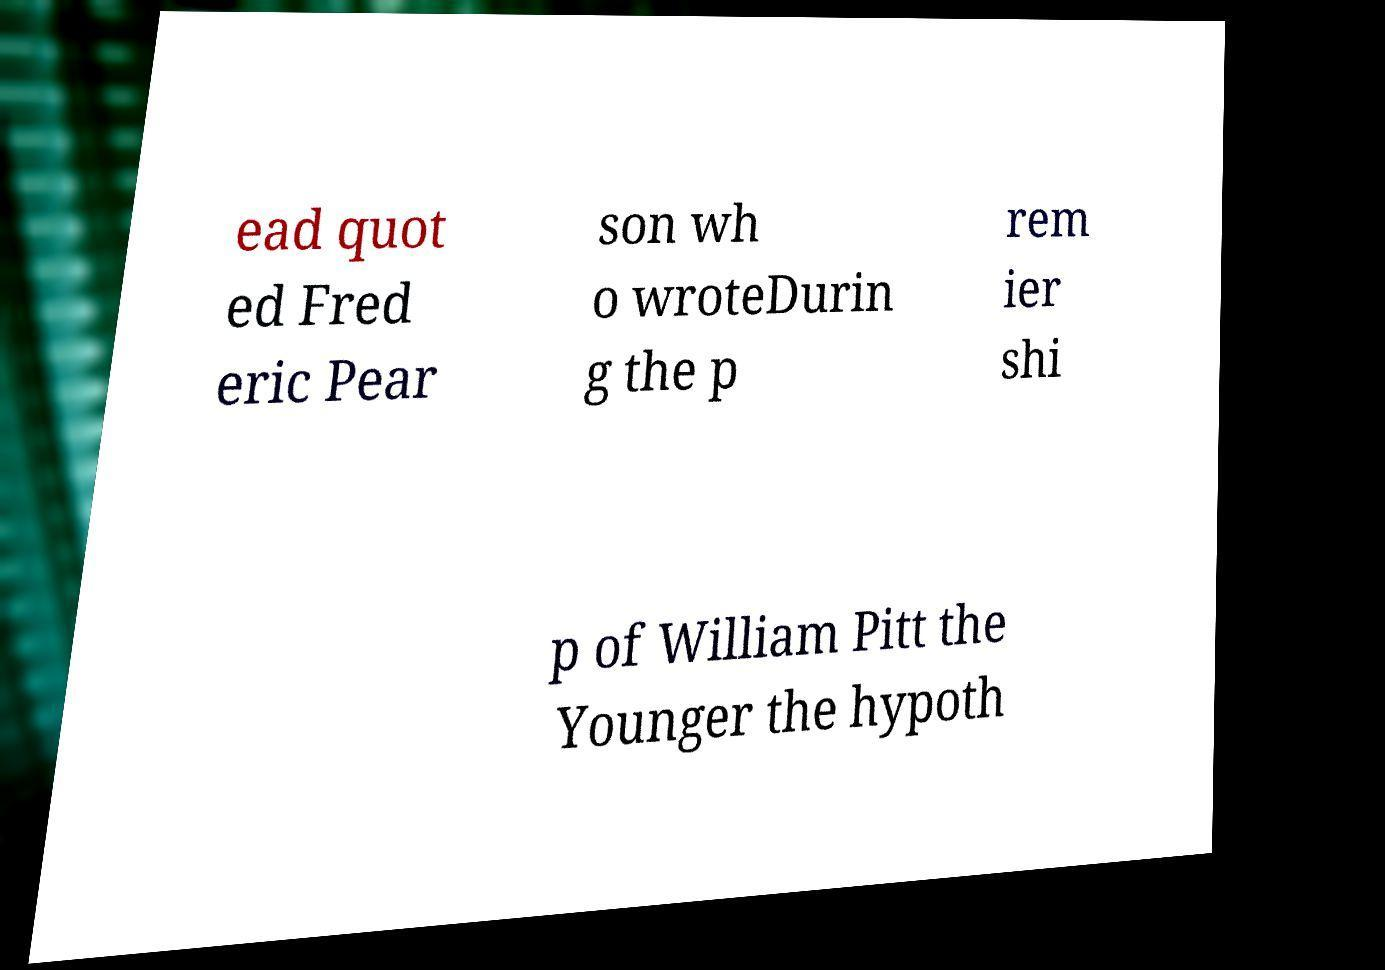Please identify and transcribe the text found in this image. ead quot ed Fred eric Pear son wh o wroteDurin g the p rem ier shi p of William Pitt the Younger the hypoth 